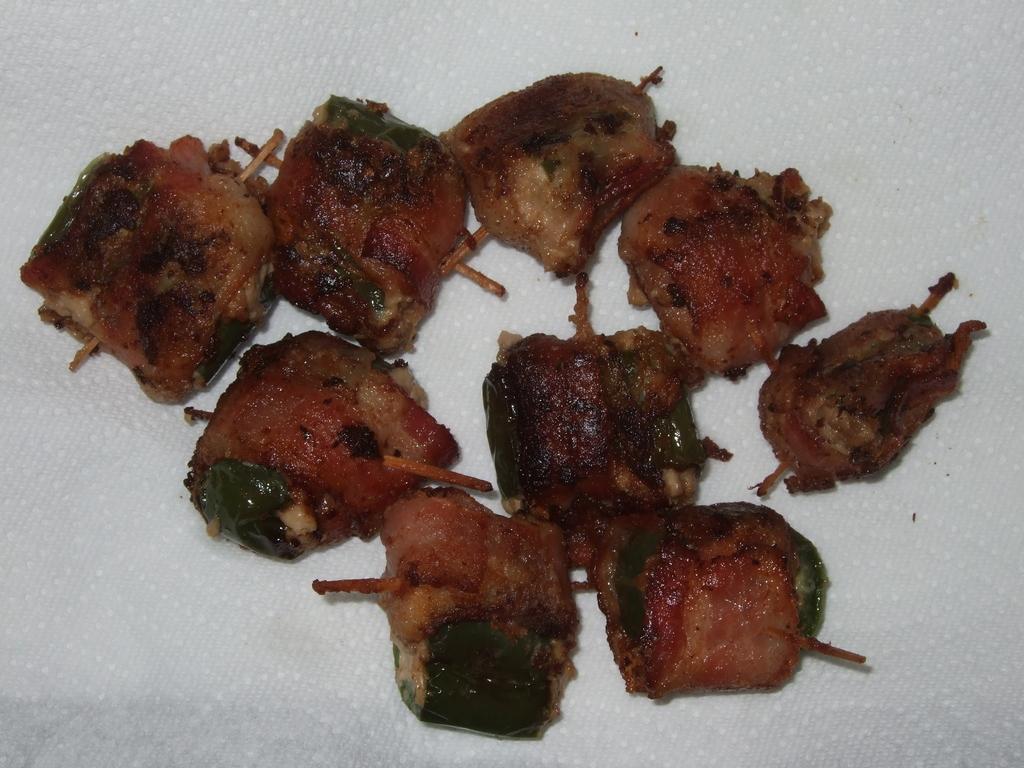Describe this image in one or two sentences. In this image there is some food on the tissue paper. Food is having few sticks in it. 